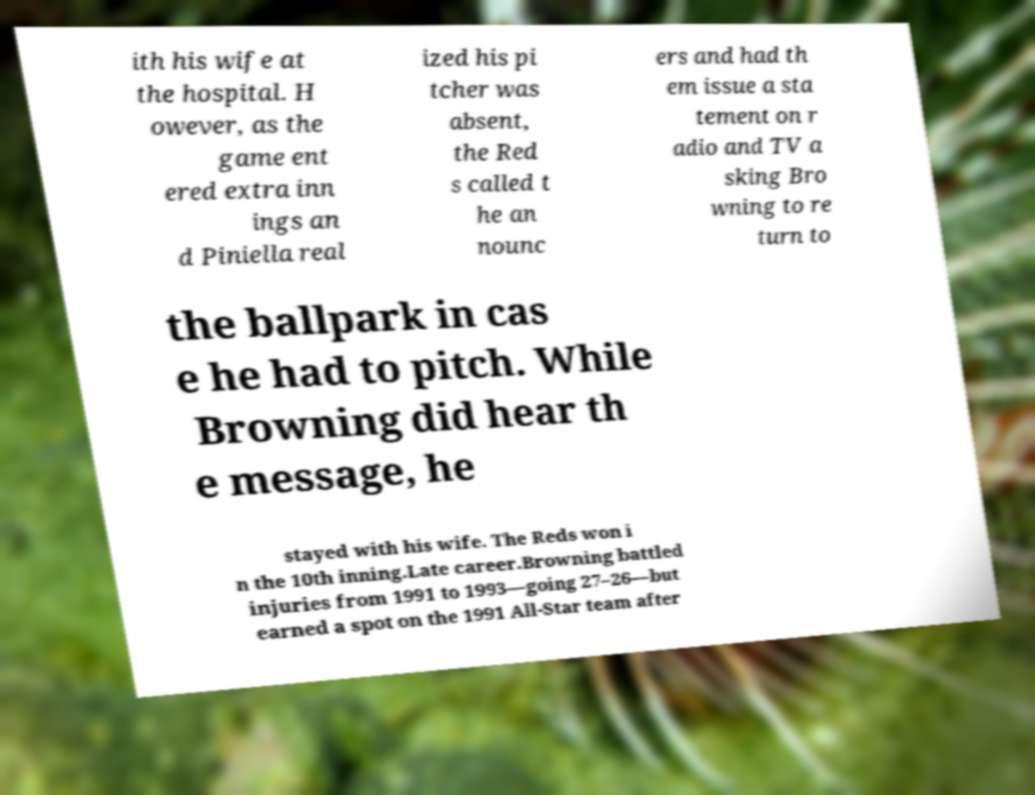Please read and relay the text visible in this image. What does it say? ith his wife at the hospital. H owever, as the game ent ered extra inn ings an d Piniella real ized his pi tcher was absent, the Red s called t he an nounc ers and had th em issue a sta tement on r adio and TV a sking Bro wning to re turn to the ballpark in cas e he had to pitch. While Browning did hear th e message, he stayed with his wife. The Reds won i n the 10th inning.Late career.Browning battled injuries from 1991 to 1993—going 27–26—but earned a spot on the 1991 All-Star team after 